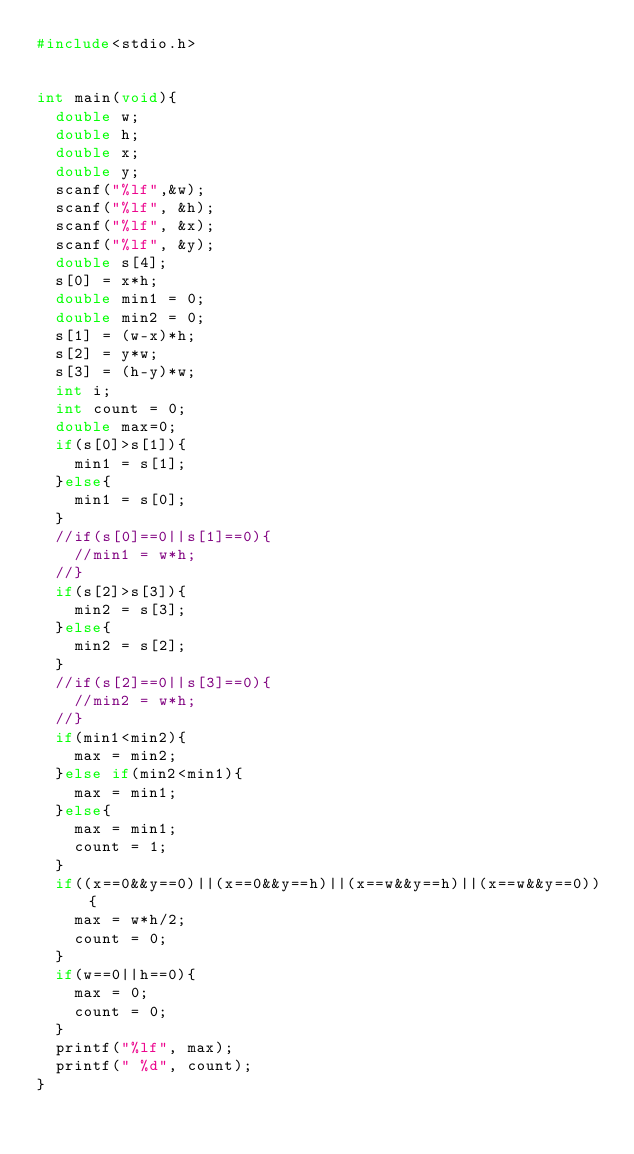Convert code to text. <code><loc_0><loc_0><loc_500><loc_500><_C_>#include<stdio.h>


int main(void){
  double w;
  double h;
  double x;
  double y;
  scanf("%lf",&w);
  scanf("%lf", &h);
  scanf("%lf", &x);
  scanf("%lf", &y);
  double s[4];
  s[0] = x*h;
  double min1 = 0;
  double min2 = 0;
  s[1] = (w-x)*h;
  s[2] = y*w;
  s[3] = (h-y)*w;
  int i;
  int count = 0;
  double max=0;
  if(s[0]>s[1]){
    min1 = s[1];
  }else{
    min1 = s[0];
  }
  //if(s[0]==0||s[1]==0){
    //min1 = w*h;
  //}
  if(s[2]>s[3]){
    min2 = s[3];
  }else{
    min2 = s[2];
  }
  //if(s[2]==0||s[3]==0){
    //min2 = w*h;
  //}
  if(min1<min2){
    max = min2;
  }else if(min2<min1){
    max = min1;
  }else{
    max = min1;
    count = 1;
  }
  if((x==0&&y==0)||(x==0&&y==h)||(x==w&&y==h)||(x==w&&y==0)){
    max = w*h/2;
    count = 0;
  }
  if(w==0||h==0){
    max = 0;
    count = 0;
  }
  printf("%lf", max);
  printf(" %d", count);
}</code> 